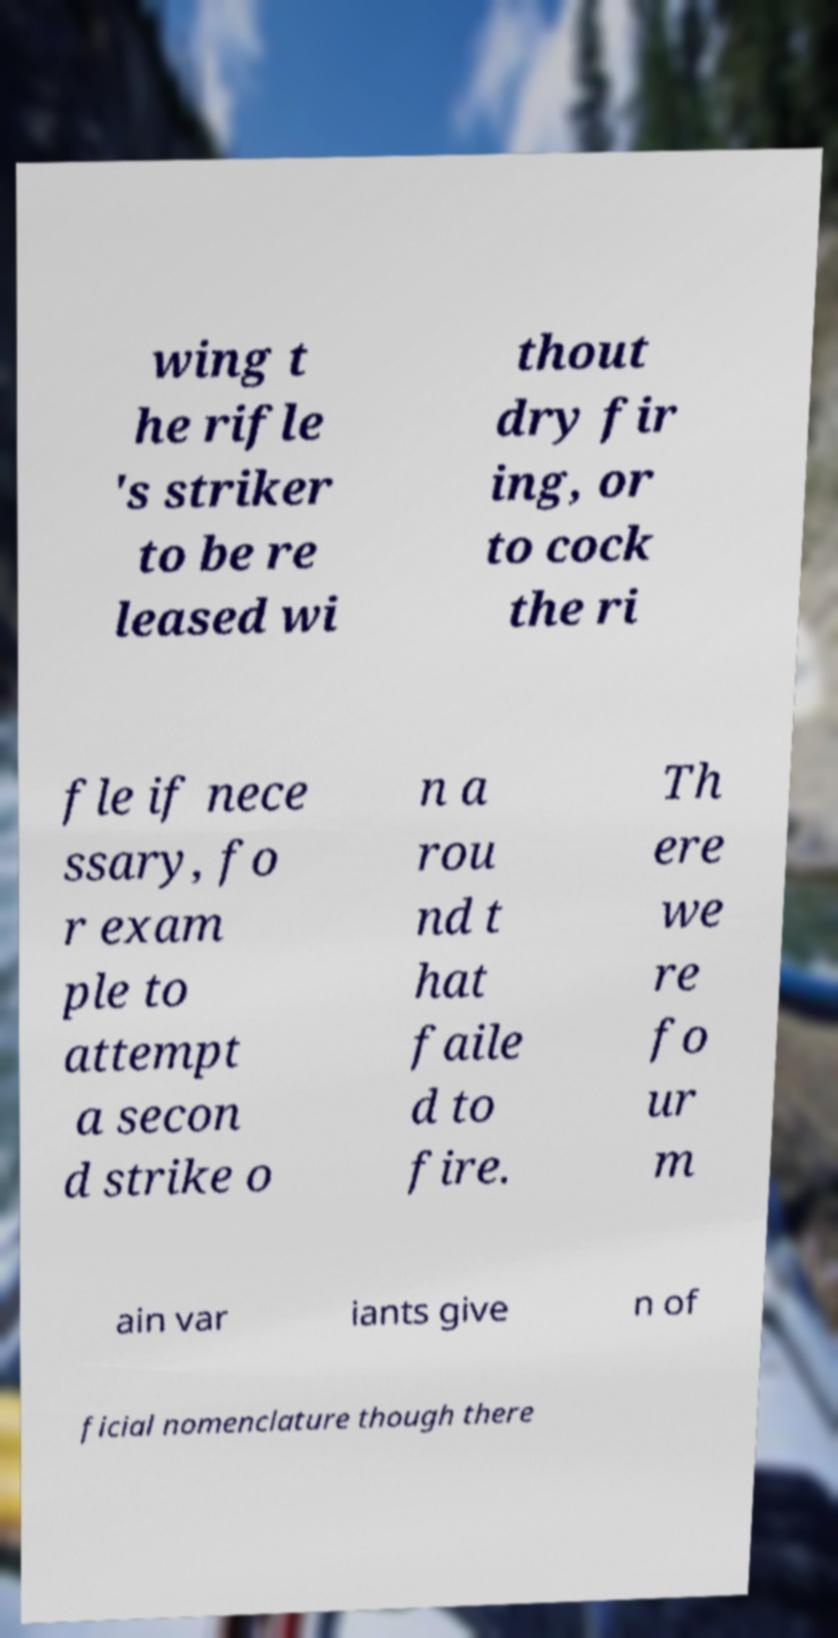Could you extract and type out the text from this image? wing t he rifle 's striker to be re leased wi thout dry fir ing, or to cock the ri fle if nece ssary, fo r exam ple to attempt a secon d strike o n a rou nd t hat faile d to fire. Th ere we re fo ur m ain var iants give n of ficial nomenclature though there 